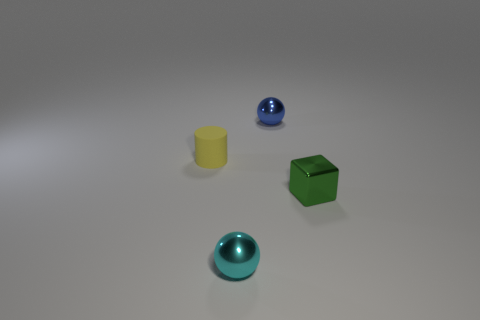Is the number of tiny green things greater than the number of tiny green balls?
Make the answer very short. Yes. Does the green thing have the same material as the small yellow cylinder?
Provide a succinct answer. No. The tiny green thing that is made of the same material as the tiny cyan sphere is what shape?
Keep it short and to the point. Cube. Are there fewer small matte things than big yellow matte cylinders?
Provide a succinct answer. No. What is the material of the object that is both on the right side of the cyan metal ball and to the left of the block?
Your answer should be compact. Metal. There is a shiny ball that is behind the tiny metal sphere to the left of the tiny sphere that is behind the green metal block; what is its size?
Keep it short and to the point. Small. Is the shape of the small yellow object the same as the metallic thing behind the green cube?
Provide a succinct answer. No. What number of balls are both left of the tiny blue metallic object and behind the small metal block?
Give a very brief answer. 0. How many gray things are either small balls or matte cylinders?
Keep it short and to the point. 0. There is a object in front of the green metal block; does it have the same color as the metal thing behind the small yellow object?
Offer a terse response. No. 